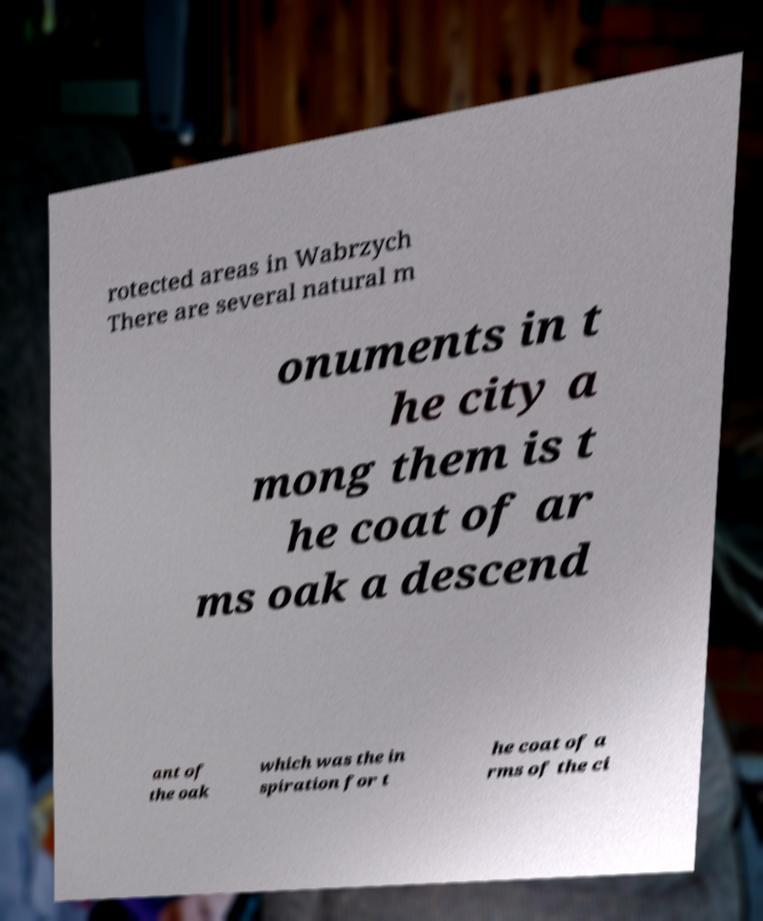For documentation purposes, I need the text within this image transcribed. Could you provide that? rotected areas in Wabrzych There are several natural m onuments in t he city a mong them is t he coat of ar ms oak a descend ant of the oak which was the in spiration for t he coat of a rms of the ci 